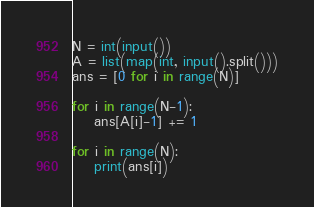<code> <loc_0><loc_0><loc_500><loc_500><_Python_>N = int(input())
A = list(map(int, input().split()))
ans = [0 for i in range(N)]

for i in range(N-1):
    ans[A[i]-1] += 1

for i in range(N):
    print(ans[i])</code> 